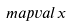Convert formula to latex. <formula><loc_0><loc_0><loc_500><loc_500>\ m a p v a l { x }</formula> 